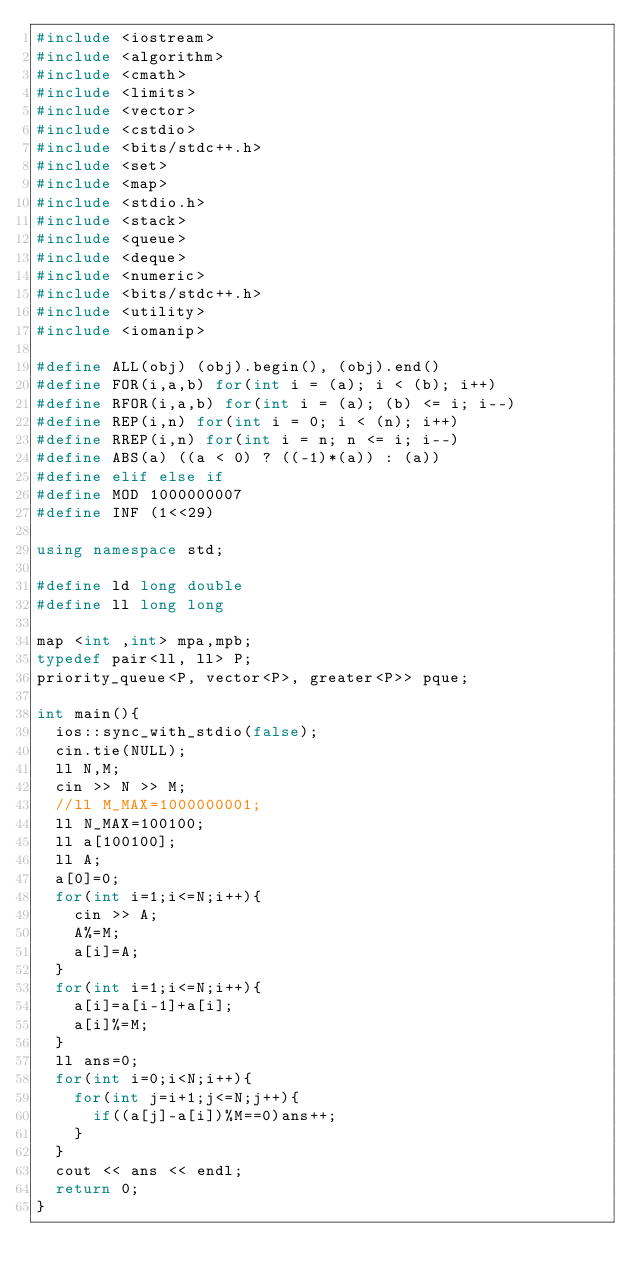Convert code to text. <code><loc_0><loc_0><loc_500><loc_500><_C++_>#include <iostream>
#include <algorithm>
#include <cmath>
#include <limits>
#include <vector>
#include <cstdio>
#include <bits/stdc++.h>
#include <set>
#include <map>
#include <stdio.h>
#include <stack>
#include <queue>
#include <deque>
#include <numeric>
#include <bits/stdc++.h>
#include <utility>
#include <iomanip>

#define ALL(obj) (obj).begin(), (obj).end()
#define FOR(i,a,b) for(int i = (a); i < (b); i++)
#define RFOR(i,a,b) for(int i = (a); (b) <= i; i--)
#define REP(i,n) for(int i = 0; i < (n); i++)
#define RREP(i,n) for(int i = n; n <= i; i--)
#define ABS(a) ((a < 0) ? ((-1)*(a)) : (a))
#define elif else if
#define MOD 1000000007
#define INF (1<<29)

using namespace std;

#define ld long double
#define ll long long

map <int ,int> mpa,mpb;
typedef pair<ll, ll> P;
priority_queue<P, vector<P>, greater<P>> pque;

int main(){
  ios::sync_with_stdio(false);
  cin.tie(NULL);
  ll N,M;
  cin >> N >> M;
  //ll M_MAX=1000000001;
  ll N_MAX=100100;
  ll a[100100];
  ll A;
  a[0]=0;
  for(int i=1;i<=N;i++){
    cin >> A;
    A%=M;
    a[i]=A;
  }
  for(int i=1;i<=N;i++){
    a[i]=a[i-1]+a[i];
    a[i]%=M;
  }
  ll ans=0;
  for(int i=0;i<N;i++){
    for(int j=i+1;j<=N;j++){
      if((a[j]-a[i])%M==0)ans++;
    }
  }
  cout << ans << endl;
  return 0;
}</code> 